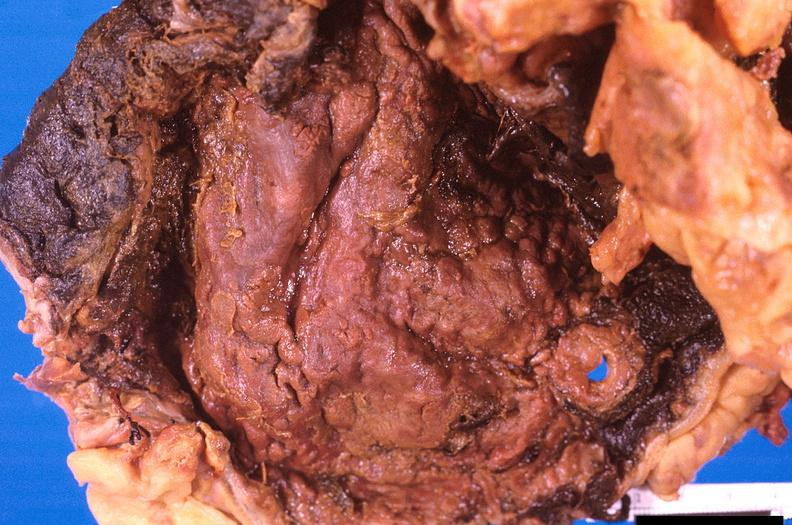s gastrointestinal present?
Answer the question using a single word or phrase. Yes 